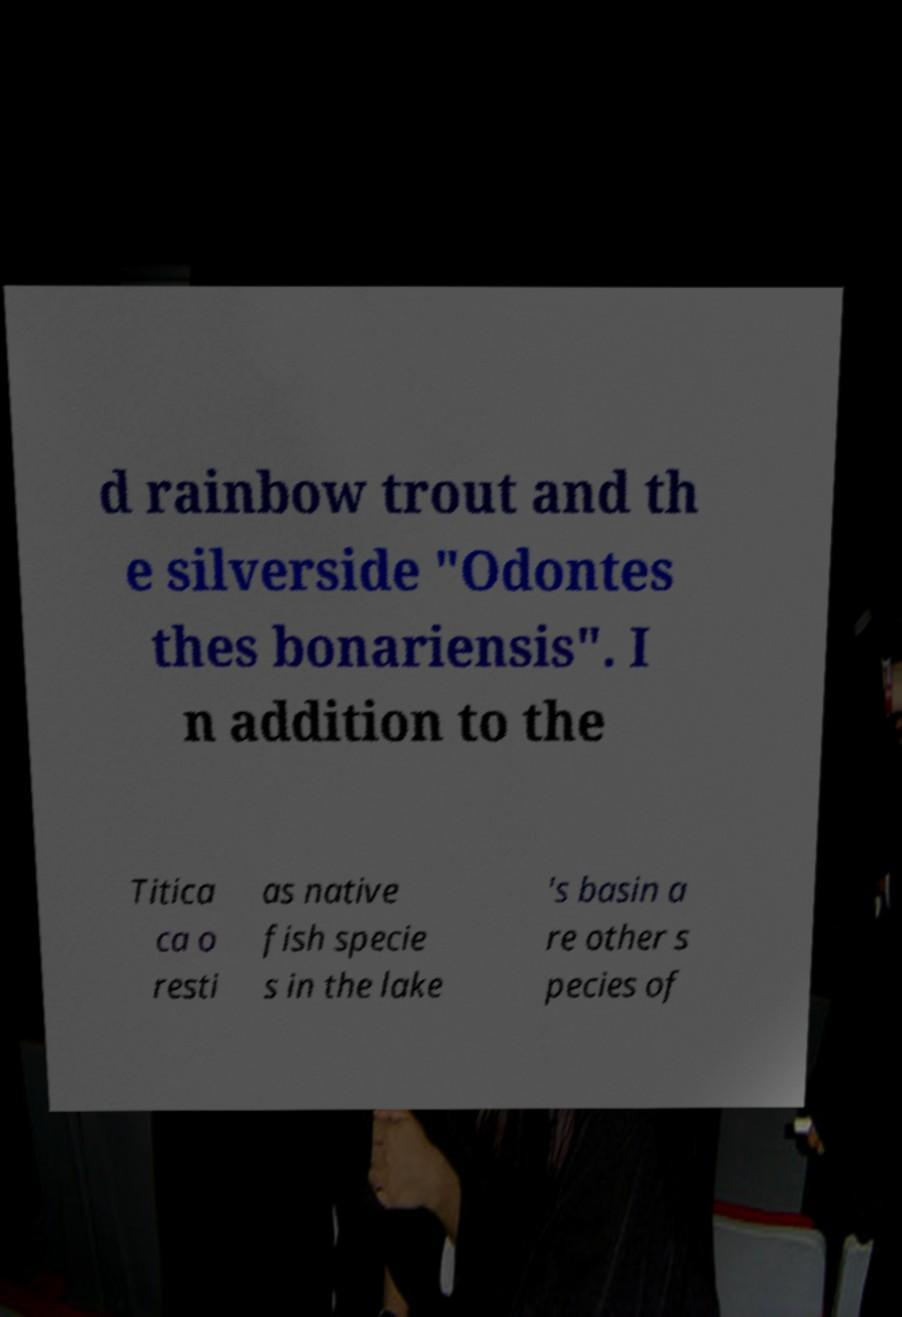Can you read and provide the text displayed in the image?This photo seems to have some interesting text. Can you extract and type it out for me? d rainbow trout and th e silverside "Odontes thes bonariensis". I n addition to the Titica ca o resti as native fish specie s in the lake 's basin a re other s pecies of 